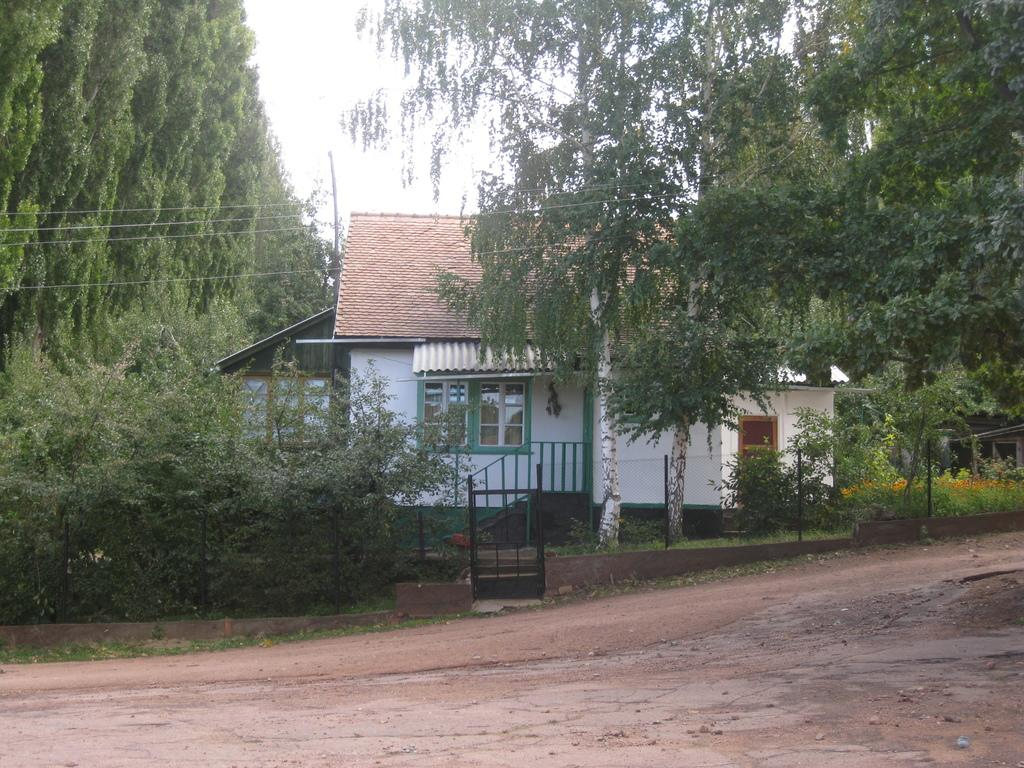What type of structures are visible in the image? There are houses in the image. What type of vegetation can be seen in the image? There are plants and trees in the image. What architectural feature is present in the image? There is a railing in the image. What type of infrastructure is visible in the image? There are electrical poles with cables in the image. What is visible at the top of the image? The sky is visible at the top of the image. What type of winter activity is taking place in the image? There is no indication of winter or any winter activities in the image. Can you hear a whistle in the image? There is no sound present in the image, so it is not possible to hear a whistle. 